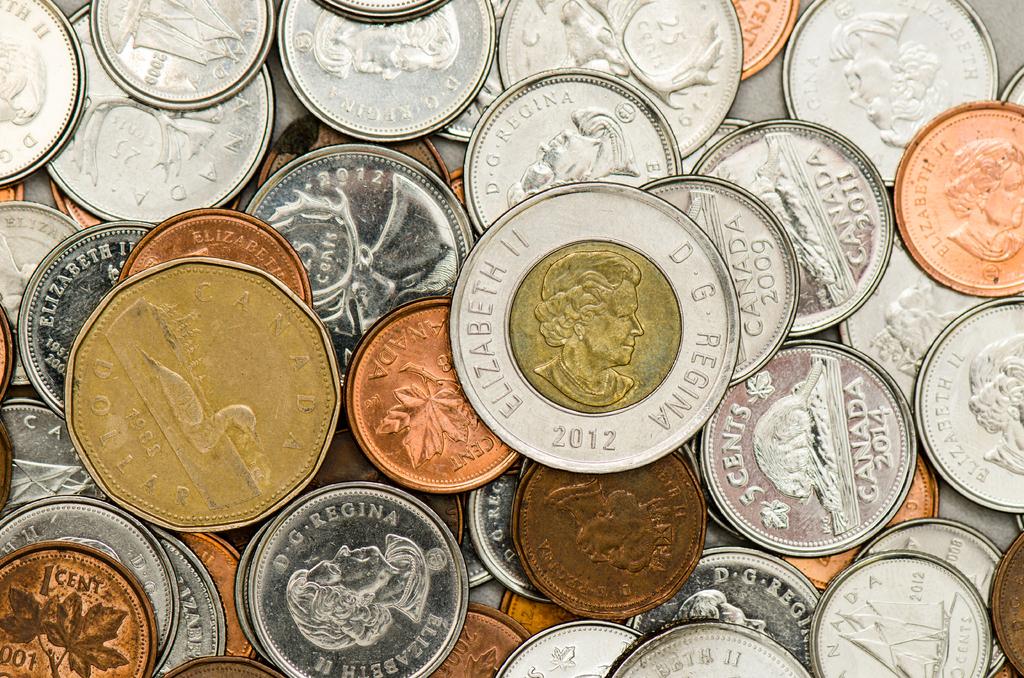What year was the largest coin made?
Ensure brevity in your answer.  2012. Whose name is written on the coin that says 2012?
Give a very brief answer. Elizabeth ii. 